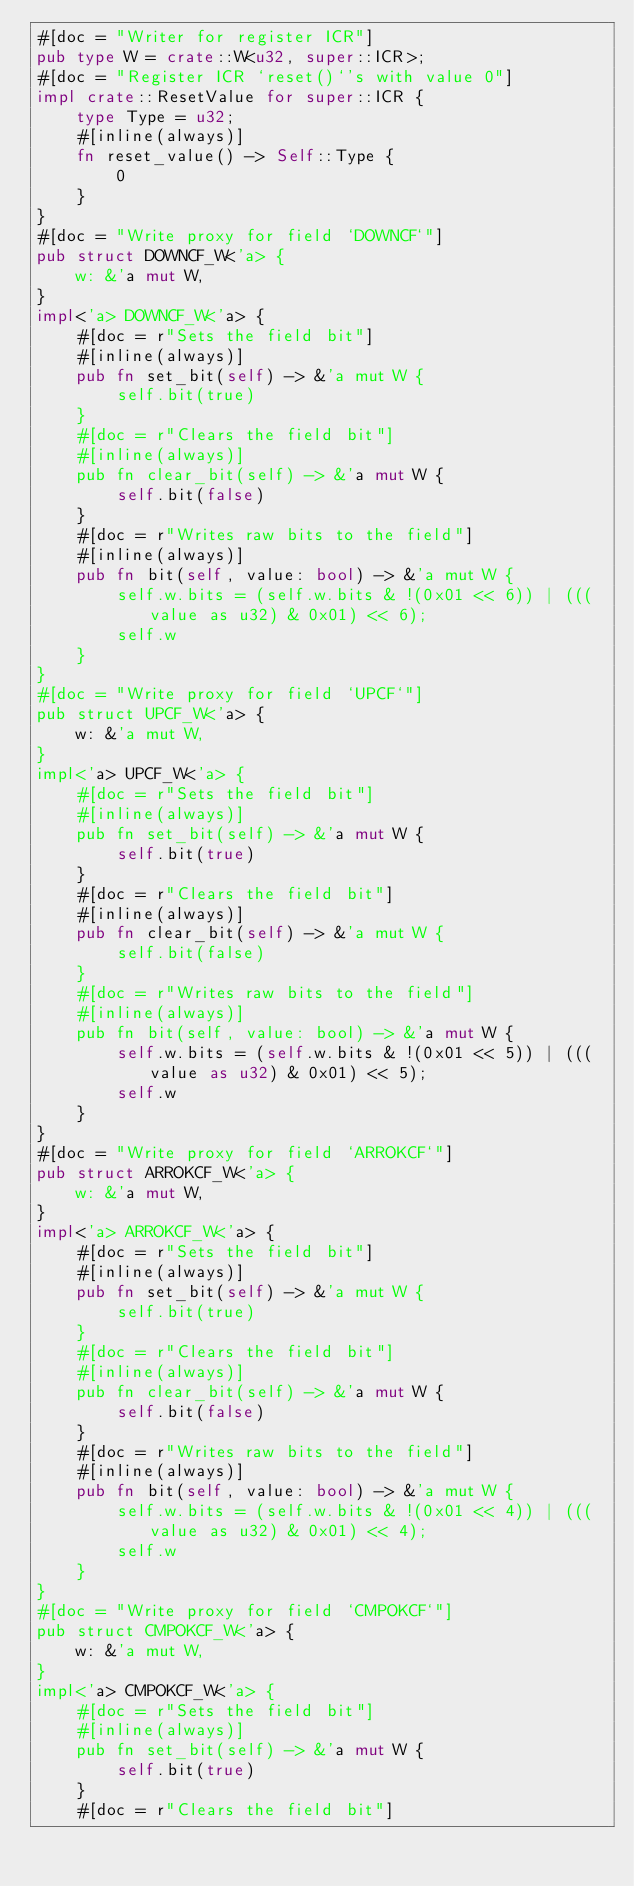<code> <loc_0><loc_0><loc_500><loc_500><_Rust_>#[doc = "Writer for register ICR"]
pub type W = crate::W<u32, super::ICR>;
#[doc = "Register ICR `reset()`'s with value 0"]
impl crate::ResetValue for super::ICR {
    type Type = u32;
    #[inline(always)]
    fn reset_value() -> Self::Type {
        0
    }
}
#[doc = "Write proxy for field `DOWNCF`"]
pub struct DOWNCF_W<'a> {
    w: &'a mut W,
}
impl<'a> DOWNCF_W<'a> {
    #[doc = r"Sets the field bit"]
    #[inline(always)]
    pub fn set_bit(self) -> &'a mut W {
        self.bit(true)
    }
    #[doc = r"Clears the field bit"]
    #[inline(always)]
    pub fn clear_bit(self) -> &'a mut W {
        self.bit(false)
    }
    #[doc = r"Writes raw bits to the field"]
    #[inline(always)]
    pub fn bit(self, value: bool) -> &'a mut W {
        self.w.bits = (self.w.bits & !(0x01 << 6)) | (((value as u32) & 0x01) << 6);
        self.w
    }
}
#[doc = "Write proxy for field `UPCF`"]
pub struct UPCF_W<'a> {
    w: &'a mut W,
}
impl<'a> UPCF_W<'a> {
    #[doc = r"Sets the field bit"]
    #[inline(always)]
    pub fn set_bit(self) -> &'a mut W {
        self.bit(true)
    }
    #[doc = r"Clears the field bit"]
    #[inline(always)]
    pub fn clear_bit(self) -> &'a mut W {
        self.bit(false)
    }
    #[doc = r"Writes raw bits to the field"]
    #[inline(always)]
    pub fn bit(self, value: bool) -> &'a mut W {
        self.w.bits = (self.w.bits & !(0x01 << 5)) | (((value as u32) & 0x01) << 5);
        self.w
    }
}
#[doc = "Write proxy for field `ARROKCF`"]
pub struct ARROKCF_W<'a> {
    w: &'a mut W,
}
impl<'a> ARROKCF_W<'a> {
    #[doc = r"Sets the field bit"]
    #[inline(always)]
    pub fn set_bit(self) -> &'a mut W {
        self.bit(true)
    }
    #[doc = r"Clears the field bit"]
    #[inline(always)]
    pub fn clear_bit(self) -> &'a mut W {
        self.bit(false)
    }
    #[doc = r"Writes raw bits to the field"]
    #[inline(always)]
    pub fn bit(self, value: bool) -> &'a mut W {
        self.w.bits = (self.w.bits & !(0x01 << 4)) | (((value as u32) & 0x01) << 4);
        self.w
    }
}
#[doc = "Write proxy for field `CMPOKCF`"]
pub struct CMPOKCF_W<'a> {
    w: &'a mut W,
}
impl<'a> CMPOKCF_W<'a> {
    #[doc = r"Sets the field bit"]
    #[inline(always)]
    pub fn set_bit(self) -> &'a mut W {
        self.bit(true)
    }
    #[doc = r"Clears the field bit"]</code> 